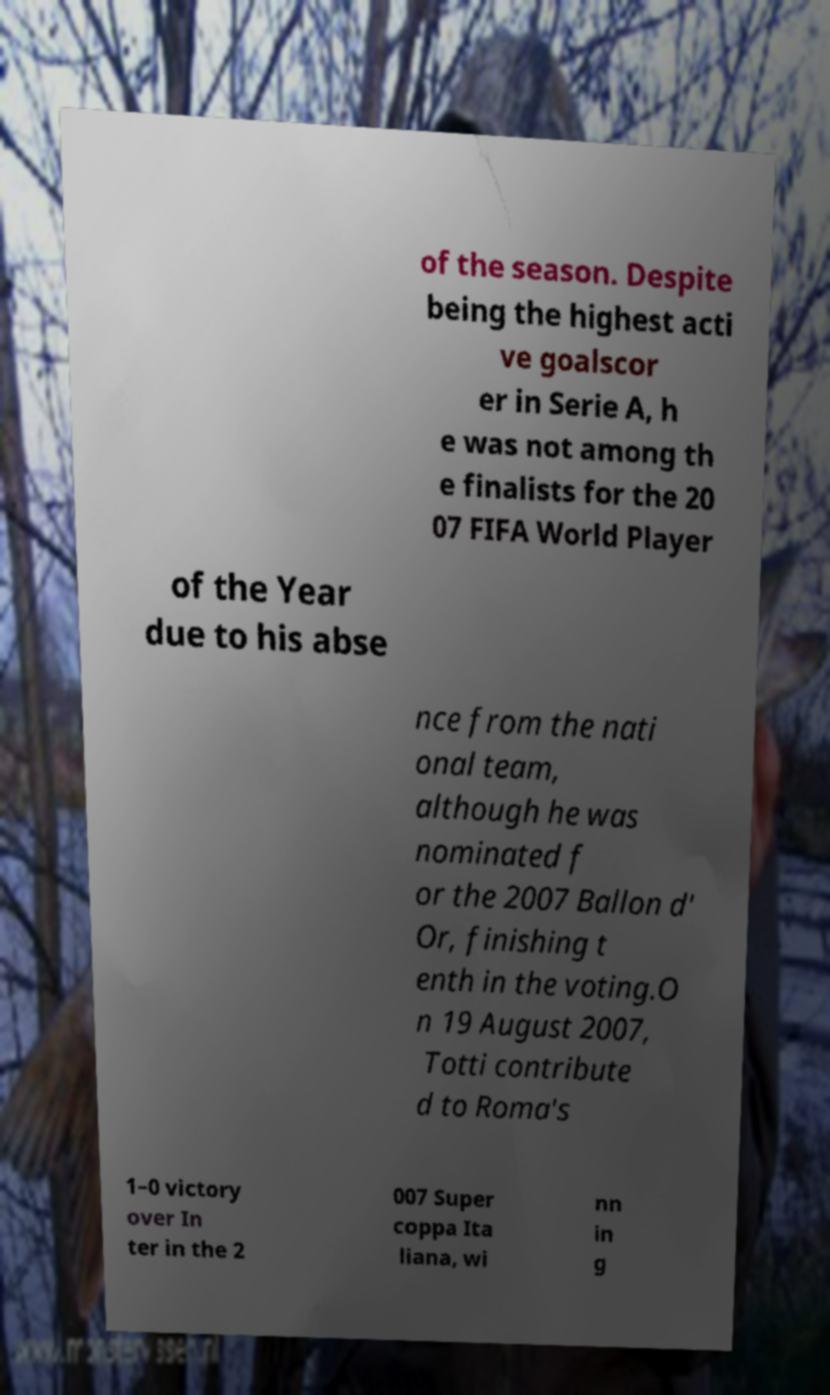Please identify and transcribe the text found in this image. of the season. Despite being the highest acti ve goalscor er in Serie A, h e was not among th e finalists for the 20 07 FIFA World Player of the Year due to his abse nce from the nati onal team, although he was nominated f or the 2007 Ballon d' Or, finishing t enth in the voting.O n 19 August 2007, Totti contribute d to Roma's 1–0 victory over In ter in the 2 007 Super coppa Ita liana, wi nn in g 